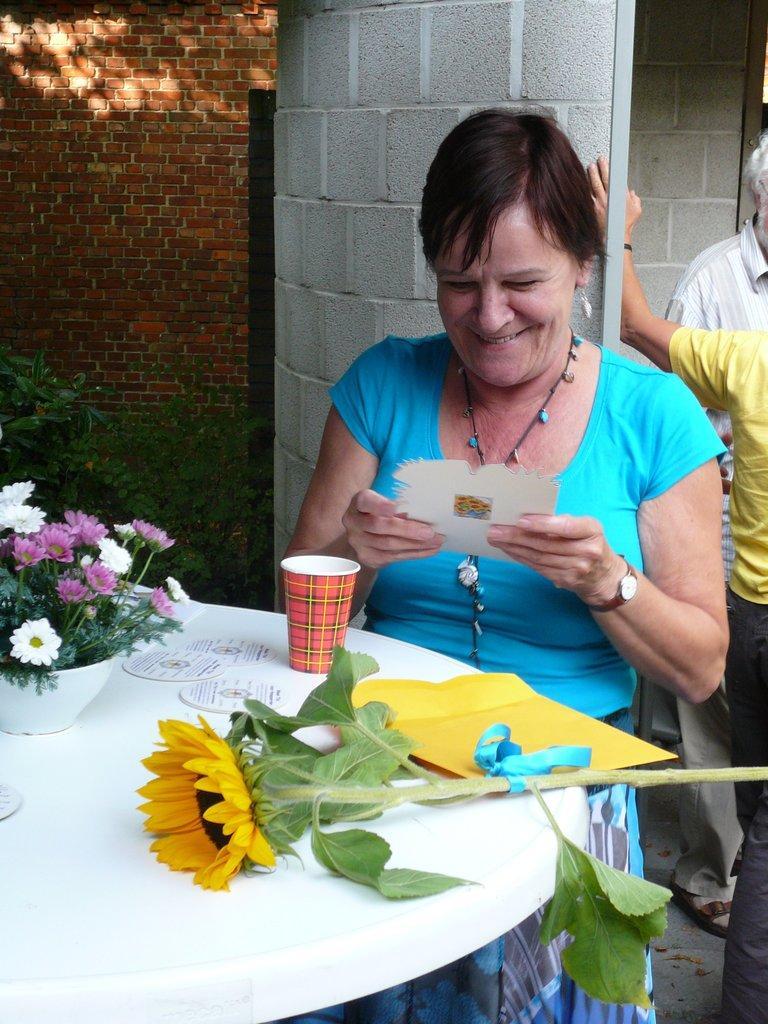In one or two sentences, can you explain what this image depicts? In this image, there is a person wearing clothes and standing in front of the table contains some flowers and cup. This person is holding a card with her hands. 